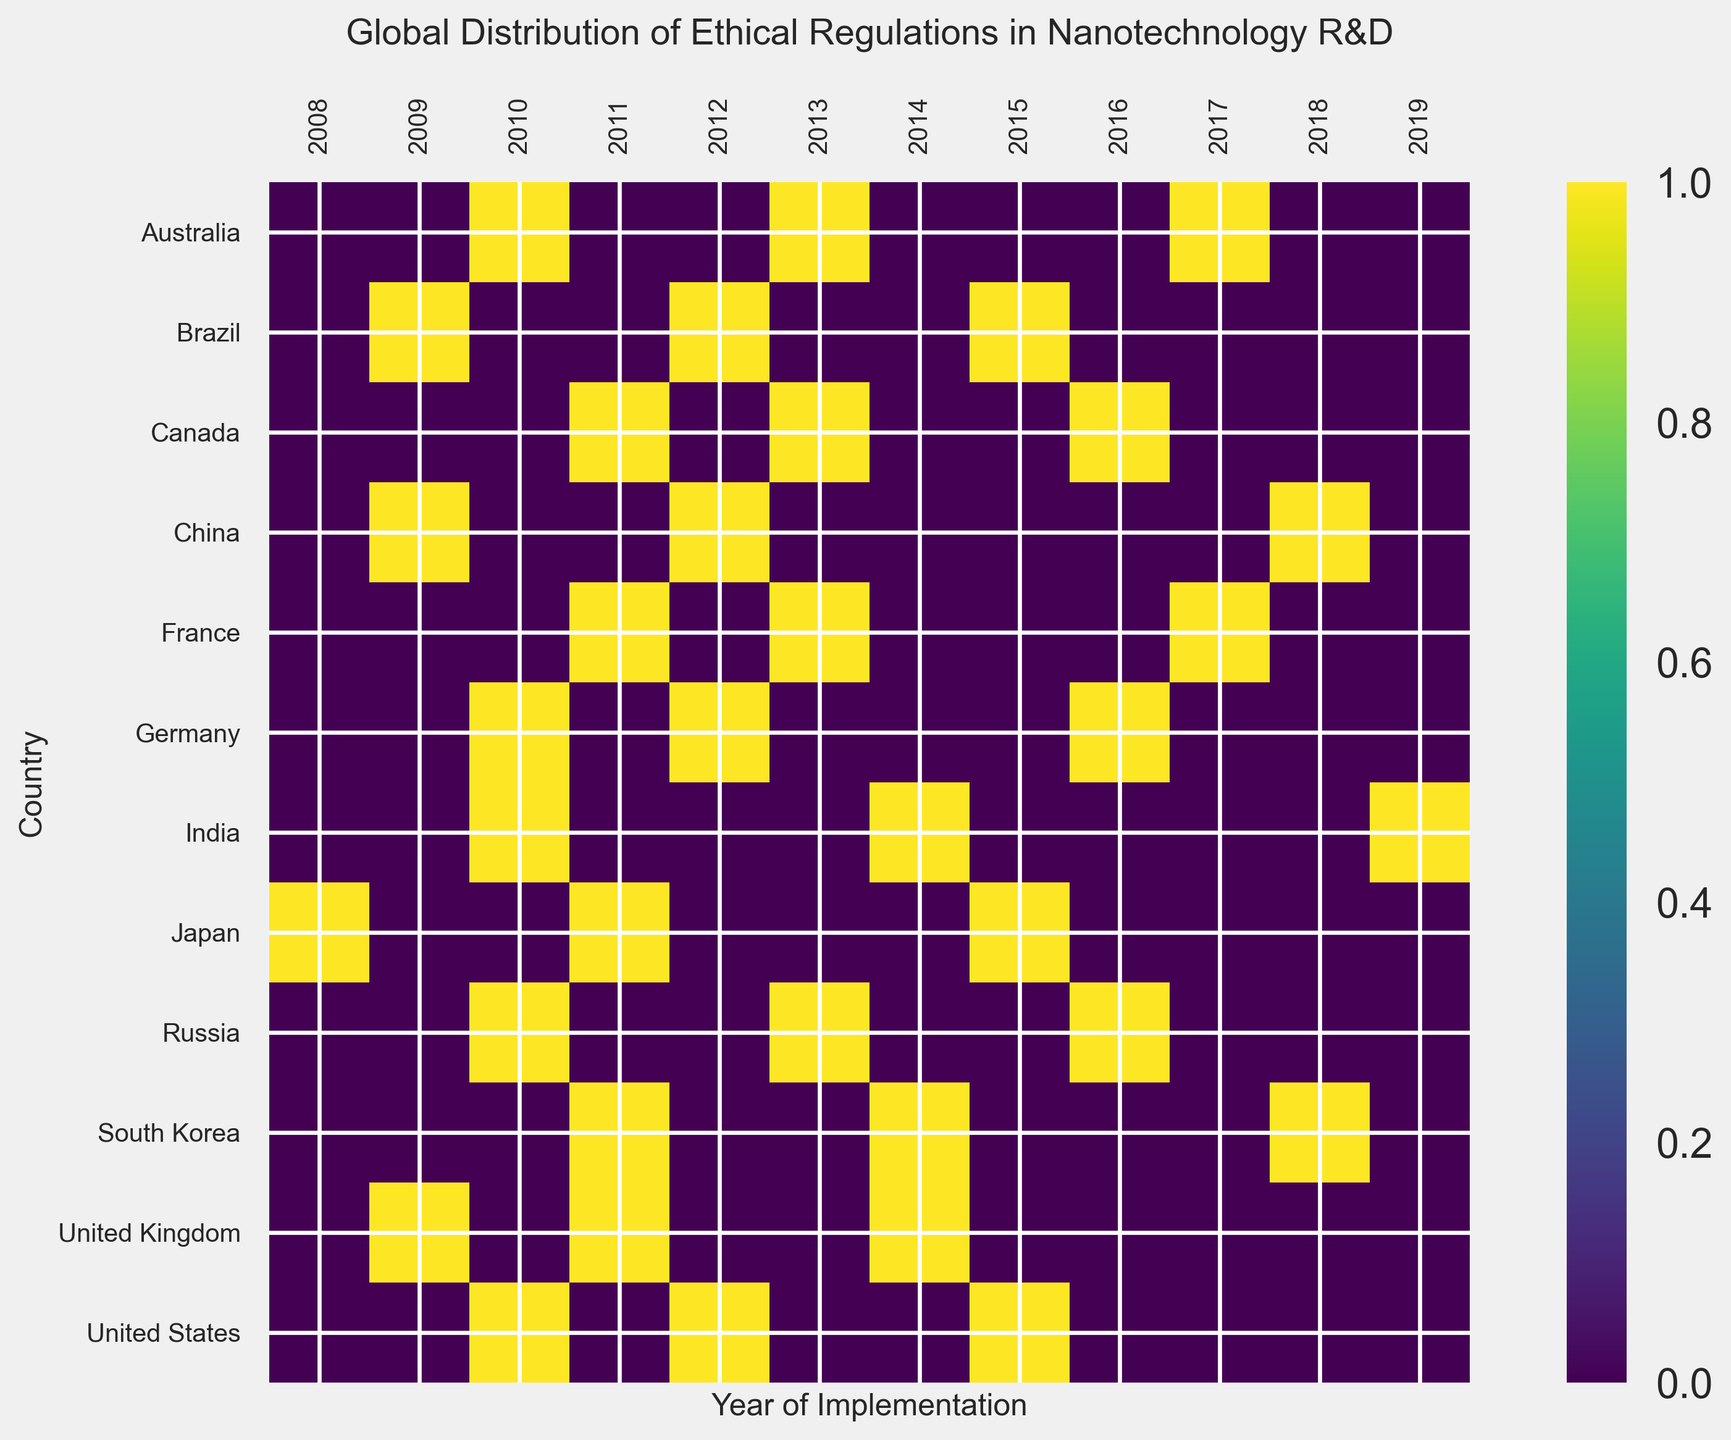Which country implemented the most ethical regulations in nanotechnology R&D between 2008 and 2019? Observe the number of occurrences of shaded squares (indicating implemented regulations) for each country. Count the occurrences and identify the country with the highest count. The United States has the most occurrences.
Answer: United States How many countries implemented ethical regulations in 2013? Count the number of shaded squares in the 2013 column of the heatmap. The countries that have regulations implemented are Canada, France, Australia, and Russia, making it a total of 4 countries.
Answer: 4 Which year had the highest number of countries implementing ethical regulations? For each column (year), count the number of shaded squares. Compare the counts across all years to identify the year with the highest count. The year 2011 has the most shaded squares.
Answer: 2011 Did the United Kingdom implement any ethical regulations in the same year as South Korea? Check if there are overlapping shaded squares for the United Kingdom and South Korea. Both countries show regulations in 2011 and 2014.
Answer: Yes In which year did both Germany and Japan implement ethical regulations? Locate the shaded squares for Germany and Japan. Both countries implemented regulations in 2011.
Answer: 2011 How many years after the earliest regulation did India implement its first ethical regulation? Identify the earliest year on the heatmap which is 2008 for Japan. India's first regulation was implemented in 2010. The difference is 2010 - 2008 = 2 years.
Answer: 2 years Which countries implemented ethical regulations in 2016? Look at the 2016 column and identify the countries with shaded squares. The countries are Germany and Russia.
Answer: Germany, Russia Did any country implement regulations consecutively over three years? Scan across the rows (years) for each country to see if there are any consecutive entries for three years. No country displays such a pattern.
Answer: No 